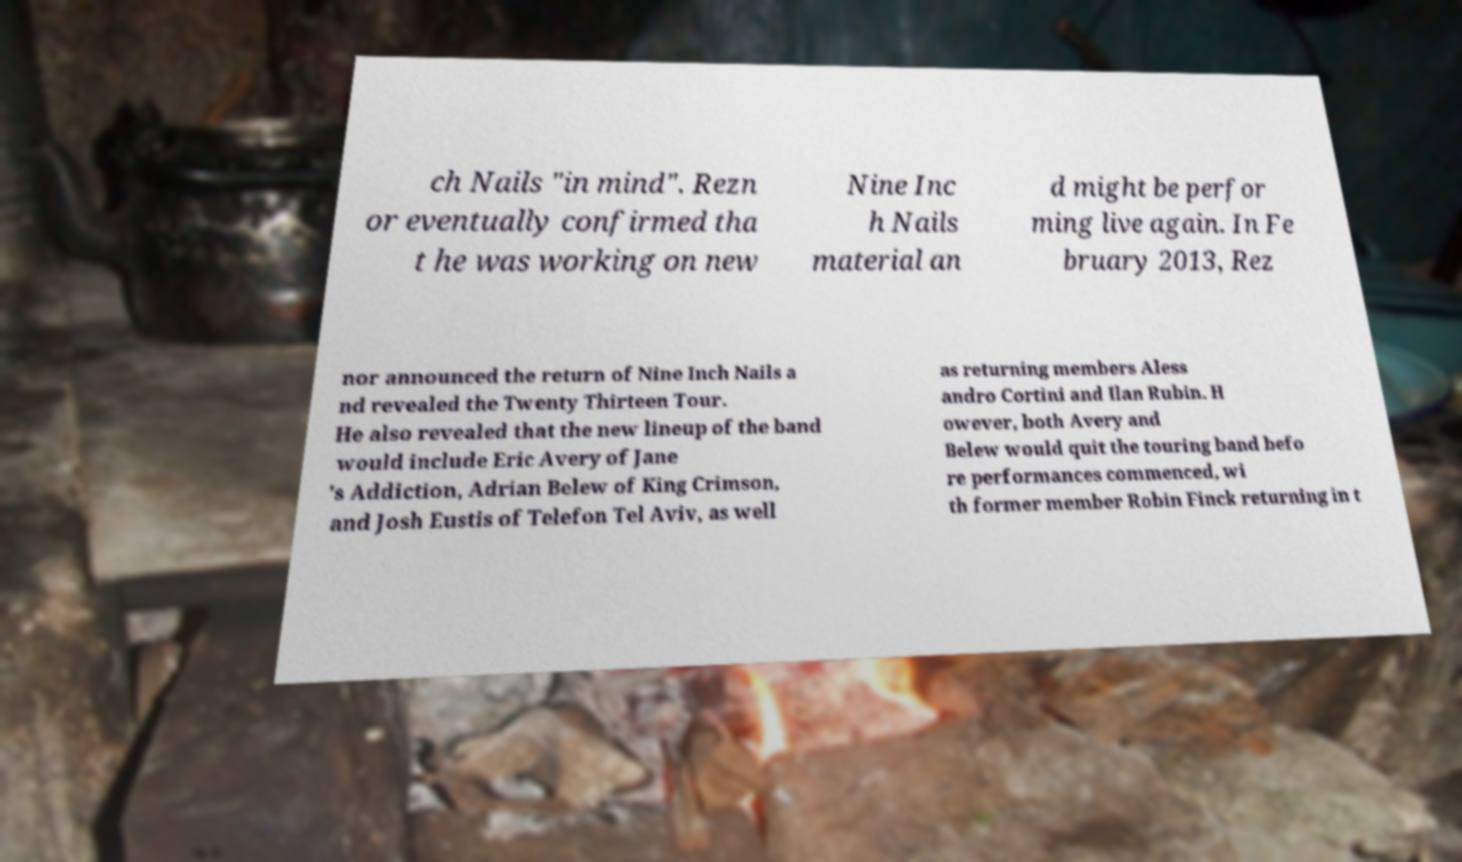Please read and relay the text visible in this image. What does it say? ch Nails "in mind". Rezn or eventually confirmed tha t he was working on new Nine Inc h Nails material an d might be perfor ming live again. In Fe bruary 2013, Rez nor announced the return of Nine Inch Nails a nd revealed the Twenty Thirteen Tour. He also revealed that the new lineup of the band would include Eric Avery of Jane 's Addiction, Adrian Belew of King Crimson, and Josh Eustis of Telefon Tel Aviv, as well as returning members Aless andro Cortini and Ilan Rubin. H owever, both Avery and Belew would quit the touring band befo re performances commenced, wi th former member Robin Finck returning in t 